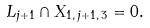Convert formula to latex. <formula><loc_0><loc_0><loc_500><loc_500>L _ { j + 1 } \cap X _ { 1 , \, j + 1 , \, 3 } = 0 .</formula> 